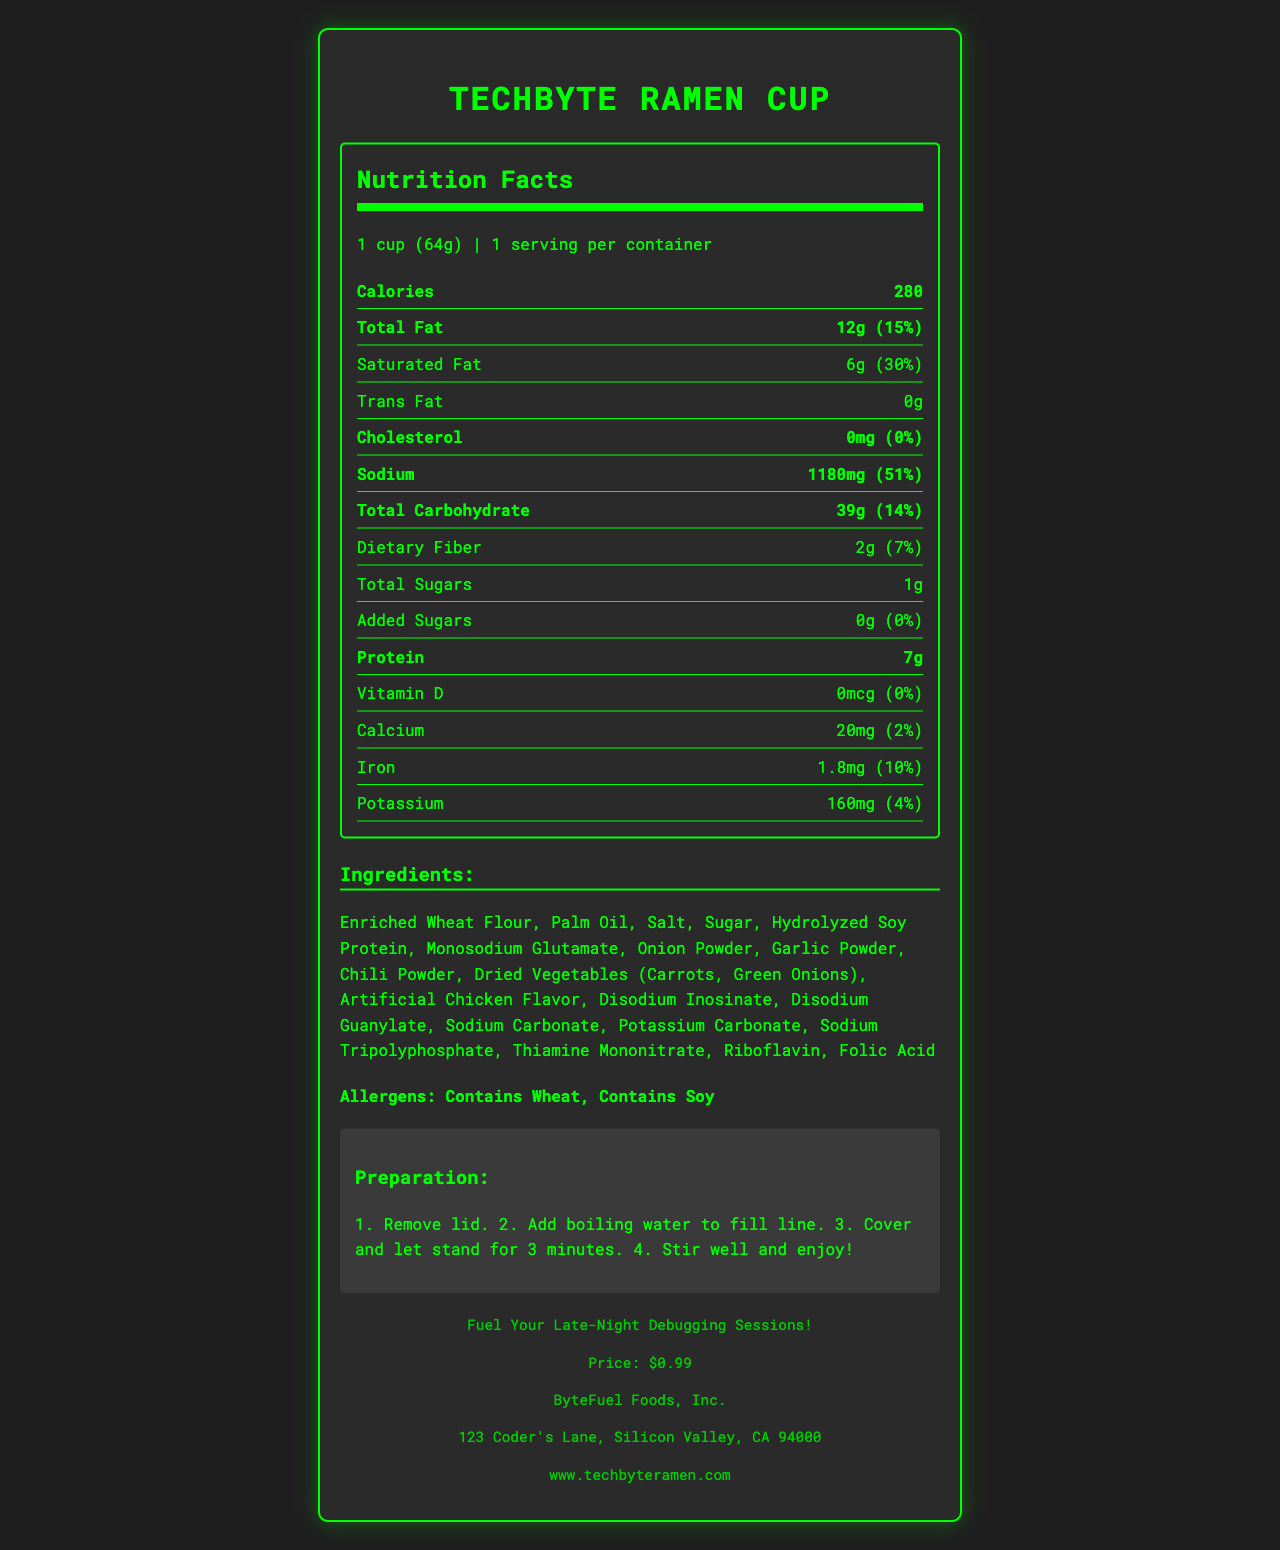What is the serving size for TechByte Ramen Cup? The document states that the serving size for TechByte Ramen Cup is “1 cup (64g).”
Answer: 1 cup (64g) How many calories are in one serving of TechByte Ramen Cup? The document specifies that there are 280 calories in one serving of the TechByte Ramen Cup.
Answer: 280 calories What is the total fat content in one serving of TechByte Ramen Cup? According to the document, the total fat content in one serving of TechByte Ramen Cup is 12g.
Answer: 12g What is the percentage daily value of sodium in one serving of TechByte Ramen Cup? The nutrition facts indicate that one serving of TechByte Ramen Cup contains 51% of the daily value for sodium.
Answer: 51% List three main ingredients in TechByte Ramen Cup. Among the ingredients listed, three main ones are Enriched Wheat Flour, Palm Oil, and Salt.
Answer: Enriched Wheat Flour, Palm Oil, Salt What is the preparation time for TechByte Ramen Cup? The preparation instructions mention that the cup should stand with boiling water for 3 minutes.
Answer: 3 minutes How much protein does TechByte Ramen Cup contain per serving? The document lists that the TechByte Ramen Cup contains 7g of protein per serving.
Answer: 7g Which vitamin is not present in TechByte Ramen Cup? A. Vitamin C B. Vitamin D C. Vitamin B12 The document states that there is 0mcg (0%) of Vitamin D in TechByte Ramen Cup.
Answer: B. Vitamin D How much iron is in one serving of TechByte Ramen Cup? A. 2% B. 5% C. 10% According to the nutrition label, one serving of TechByte Ramen Cup contains 1.8mg of iron, which is 10% of the daily value.
Answer: C. 10% Does TechByte Ramen Cup contain any allergens? The document clearly states that TechByte Ramen Cup contains Wheat and Soy as allergens.
Answer: Yes Summarize the main nutritional facts and other important details provided about TechByte Ramen Cup. This summary captures the essential nutritional information, preparation instructions, ingredient list, allergen information, and general product details provided in the document.
Answer: TechByte Ramen Cup is an instant noodle product with a serving size of 1 cup (64g) and 280 calories per serving. Key nutrition facts include 12g of total fat, 51% of daily sodium, and 39g of carbohydrates. It also contains 7g of protein, trace amounts of calcium, iron, and potassium. The ingredients list includes Enriched Wheat Flour, Palm Oil, Salt, and several other flavoring agents. The product contains Wheat and Soy as allergens and should be stored in a cool, dry place. It is manufactured by ByteFuel Foods, Inc., and priced at $0.99. How many milligrams of potassium are in a serving of TechByte Ramen Cup? The document notes that there are 160mg of potassium per serving in TechByte Ramen Cup.
Answer: 160mg Is there any cholesterol in TechByte Ramen Cup? The label indicates that the cholesterol content in TechByte Ramen Cup is 0mg, or 0% of the daily value.
Answer: No What is the sodium content of TechByte Ramen Cup compared to the total carbohydrate content? The document states that one serving of TechByte Ramen Cup contains 1180mg of sodium and 39g of total carbohydrates.
Answer: 1180mg sodium, 39g total carbohydrate Who manufactures TechByte Ramen Cup? The manufacturer's information provided in the document states that ByteFuel Foods, Inc. is the manufacturer.
Answer: ByteFuel Foods, Inc. Can TechByte Ramen Cup be considered a low-sodium food? With 1180mg of sodium per serving, which constitutes 51% of the daily value, TechByte Ramen Cup cannot be considered a low-sodium food.
Answer: No What is the price of TechByte Ramen Cup? The document specifies that the price of TechByte Ramen Cup is $0.99.
Answer: $0.99 What is the purpose of this product according to its slogan? The slogan of TechByte Ramen Cup is "Fuel Your Late-Night Debugging Sessions!"
Answer: To fuel late-night debugging sessions What are the cooking instructions for TechByte Ramen Cup? The preparation section details these steps for cooking TechByte Ramen Cup.
Answer: Remove lid, add boiling water to fill line, cover, let stand for 3 minutes, stir well, and enjoy What percentage of the daily value of dietary fiber is in a serving? The document states that there is 7% of the daily value of dietary fiber in one serving of TechByte Ramen Cup.
Answer: 7% Where is ByteFuel Foods, Inc. located? The address provided for the manufacturer is 123 Coder's Lane, Silicon Valley, CA 94000.
Answer: 123 Coder's Lane, Silicon Valley, CA 94000 Is this product gluten-free? The product contains Enriched Wheat Flour, which means it is not gluten-free.
Answer: No 